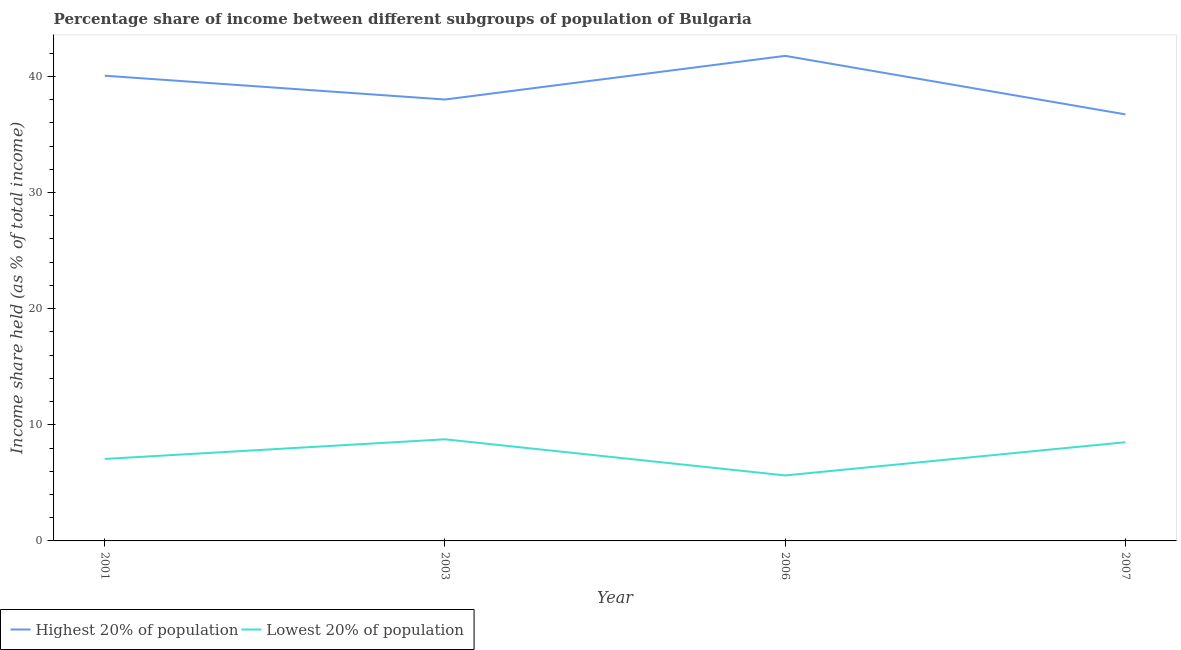Does the line corresponding to income share held by highest 20% of the population intersect with the line corresponding to income share held by lowest 20% of the population?
Offer a terse response. No. Is the number of lines equal to the number of legend labels?
Offer a very short reply. Yes. What is the income share held by highest 20% of the population in 2006?
Give a very brief answer. 41.77. Across all years, what is the maximum income share held by lowest 20% of the population?
Offer a terse response. 8.75. Across all years, what is the minimum income share held by highest 20% of the population?
Provide a succinct answer. 36.73. What is the total income share held by lowest 20% of the population in the graph?
Keep it short and to the point. 29.95. What is the difference between the income share held by lowest 20% of the population in 2001 and that in 2007?
Your answer should be very brief. -1.44. What is the difference between the income share held by highest 20% of the population in 2003 and the income share held by lowest 20% of the population in 2007?
Provide a succinct answer. 29.51. What is the average income share held by lowest 20% of the population per year?
Offer a terse response. 7.49. In the year 2003, what is the difference between the income share held by lowest 20% of the population and income share held by highest 20% of the population?
Your answer should be very brief. -29.26. In how many years, is the income share held by lowest 20% of the population greater than 12 %?
Offer a terse response. 0. What is the ratio of the income share held by lowest 20% of the population in 2001 to that in 2003?
Make the answer very short. 0.81. Is the income share held by highest 20% of the population in 2003 less than that in 2007?
Offer a very short reply. No. What is the difference between the highest and the second highest income share held by highest 20% of the population?
Your response must be concise. 1.71. What is the difference between the highest and the lowest income share held by highest 20% of the population?
Provide a short and direct response. 5.04. In how many years, is the income share held by highest 20% of the population greater than the average income share held by highest 20% of the population taken over all years?
Offer a very short reply. 2. Is the sum of the income share held by highest 20% of the population in 2003 and 2007 greater than the maximum income share held by lowest 20% of the population across all years?
Ensure brevity in your answer.  Yes. Is the income share held by highest 20% of the population strictly greater than the income share held by lowest 20% of the population over the years?
Your response must be concise. Yes. Is the income share held by highest 20% of the population strictly less than the income share held by lowest 20% of the population over the years?
Ensure brevity in your answer.  No. What is the difference between two consecutive major ticks on the Y-axis?
Your answer should be compact. 10. Are the values on the major ticks of Y-axis written in scientific E-notation?
Ensure brevity in your answer.  No. Does the graph contain any zero values?
Your answer should be compact. No. Does the graph contain grids?
Keep it short and to the point. No. How many legend labels are there?
Ensure brevity in your answer.  2. What is the title of the graph?
Make the answer very short. Percentage share of income between different subgroups of population of Bulgaria. Does "Passenger Transport Items" appear as one of the legend labels in the graph?
Provide a short and direct response. No. What is the label or title of the X-axis?
Your answer should be very brief. Year. What is the label or title of the Y-axis?
Keep it short and to the point. Income share held (as % of total income). What is the Income share held (as % of total income) of Highest 20% of population in 2001?
Provide a short and direct response. 40.06. What is the Income share held (as % of total income) in Lowest 20% of population in 2001?
Keep it short and to the point. 7.06. What is the Income share held (as % of total income) in Highest 20% of population in 2003?
Offer a terse response. 38.01. What is the Income share held (as % of total income) of Lowest 20% of population in 2003?
Give a very brief answer. 8.75. What is the Income share held (as % of total income) in Highest 20% of population in 2006?
Your answer should be very brief. 41.77. What is the Income share held (as % of total income) of Lowest 20% of population in 2006?
Provide a short and direct response. 5.64. What is the Income share held (as % of total income) in Highest 20% of population in 2007?
Your answer should be compact. 36.73. What is the Income share held (as % of total income) in Lowest 20% of population in 2007?
Your answer should be very brief. 8.5. Across all years, what is the maximum Income share held (as % of total income) in Highest 20% of population?
Offer a terse response. 41.77. Across all years, what is the maximum Income share held (as % of total income) in Lowest 20% of population?
Offer a very short reply. 8.75. Across all years, what is the minimum Income share held (as % of total income) of Highest 20% of population?
Provide a succinct answer. 36.73. Across all years, what is the minimum Income share held (as % of total income) of Lowest 20% of population?
Your response must be concise. 5.64. What is the total Income share held (as % of total income) in Highest 20% of population in the graph?
Offer a very short reply. 156.57. What is the total Income share held (as % of total income) of Lowest 20% of population in the graph?
Provide a short and direct response. 29.95. What is the difference between the Income share held (as % of total income) of Highest 20% of population in 2001 and that in 2003?
Your response must be concise. 2.05. What is the difference between the Income share held (as % of total income) in Lowest 20% of population in 2001 and that in 2003?
Provide a succinct answer. -1.69. What is the difference between the Income share held (as % of total income) of Highest 20% of population in 2001 and that in 2006?
Your answer should be very brief. -1.71. What is the difference between the Income share held (as % of total income) in Lowest 20% of population in 2001 and that in 2006?
Provide a short and direct response. 1.42. What is the difference between the Income share held (as % of total income) of Highest 20% of population in 2001 and that in 2007?
Ensure brevity in your answer.  3.33. What is the difference between the Income share held (as % of total income) in Lowest 20% of population in 2001 and that in 2007?
Your answer should be very brief. -1.44. What is the difference between the Income share held (as % of total income) of Highest 20% of population in 2003 and that in 2006?
Make the answer very short. -3.76. What is the difference between the Income share held (as % of total income) in Lowest 20% of population in 2003 and that in 2006?
Your answer should be compact. 3.11. What is the difference between the Income share held (as % of total income) of Highest 20% of population in 2003 and that in 2007?
Your response must be concise. 1.28. What is the difference between the Income share held (as % of total income) in Highest 20% of population in 2006 and that in 2007?
Your answer should be very brief. 5.04. What is the difference between the Income share held (as % of total income) of Lowest 20% of population in 2006 and that in 2007?
Ensure brevity in your answer.  -2.86. What is the difference between the Income share held (as % of total income) of Highest 20% of population in 2001 and the Income share held (as % of total income) of Lowest 20% of population in 2003?
Provide a short and direct response. 31.31. What is the difference between the Income share held (as % of total income) of Highest 20% of population in 2001 and the Income share held (as % of total income) of Lowest 20% of population in 2006?
Keep it short and to the point. 34.42. What is the difference between the Income share held (as % of total income) in Highest 20% of population in 2001 and the Income share held (as % of total income) in Lowest 20% of population in 2007?
Give a very brief answer. 31.56. What is the difference between the Income share held (as % of total income) in Highest 20% of population in 2003 and the Income share held (as % of total income) in Lowest 20% of population in 2006?
Your response must be concise. 32.37. What is the difference between the Income share held (as % of total income) in Highest 20% of population in 2003 and the Income share held (as % of total income) in Lowest 20% of population in 2007?
Offer a very short reply. 29.51. What is the difference between the Income share held (as % of total income) in Highest 20% of population in 2006 and the Income share held (as % of total income) in Lowest 20% of population in 2007?
Give a very brief answer. 33.27. What is the average Income share held (as % of total income) in Highest 20% of population per year?
Offer a very short reply. 39.14. What is the average Income share held (as % of total income) in Lowest 20% of population per year?
Keep it short and to the point. 7.49. In the year 2003, what is the difference between the Income share held (as % of total income) in Highest 20% of population and Income share held (as % of total income) in Lowest 20% of population?
Your answer should be very brief. 29.26. In the year 2006, what is the difference between the Income share held (as % of total income) of Highest 20% of population and Income share held (as % of total income) of Lowest 20% of population?
Your answer should be very brief. 36.13. In the year 2007, what is the difference between the Income share held (as % of total income) of Highest 20% of population and Income share held (as % of total income) of Lowest 20% of population?
Your answer should be compact. 28.23. What is the ratio of the Income share held (as % of total income) of Highest 20% of population in 2001 to that in 2003?
Give a very brief answer. 1.05. What is the ratio of the Income share held (as % of total income) of Lowest 20% of population in 2001 to that in 2003?
Your answer should be compact. 0.81. What is the ratio of the Income share held (as % of total income) in Highest 20% of population in 2001 to that in 2006?
Your answer should be very brief. 0.96. What is the ratio of the Income share held (as % of total income) of Lowest 20% of population in 2001 to that in 2006?
Give a very brief answer. 1.25. What is the ratio of the Income share held (as % of total income) in Highest 20% of population in 2001 to that in 2007?
Your answer should be compact. 1.09. What is the ratio of the Income share held (as % of total income) in Lowest 20% of population in 2001 to that in 2007?
Offer a terse response. 0.83. What is the ratio of the Income share held (as % of total income) of Highest 20% of population in 2003 to that in 2006?
Keep it short and to the point. 0.91. What is the ratio of the Income share held (as % of total income) in Lowest 20% of population in 2003 to that in 2006?
Your answer should be compact. 1.55. What is the ratio of the Income share held (as % of total income) of Highest 20% of population in 2003 to that in 2007?
Provide a short and direct response. 1.03. What is the ratio of the Income share held (as % of total income) of Lowest 20% of population in 2003 to that in 2007?
Offer a very short reply. 1.03. What is the ratio of the Income share held (as % of total income) of Highest 20% of population in 2006 to that in 2007?
Ensure brevity in your answer.  1.14. What is the ratio of the Income share held (as % of total income) in Lowest 20% of population in 2006 to that in 2007?
Keep it short and to the point. 0.66. What is the difference between the highest and the second highest Income share held (as % of total income) of Highest 20% of population?
Give a very brief answer. 1.71. What is the difference between the highest and the second highest Income share held (as % of total income) of Lowest 20% of population?
Offer a terse response. 0.25. What is the difference between the highest and the lowest Income share held (as % of total income) of Highest 20% of population?
Offer a very short reply. 5.04. What is the difference between the highest and the lowest Income share held (as % of total income) in Lowest 20% of population?
Keep it short and to the point. 3.11. 